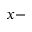Convert formula to latex. <formula><loc_0><loc_0><loc_500><loc_500>x -</formula> 